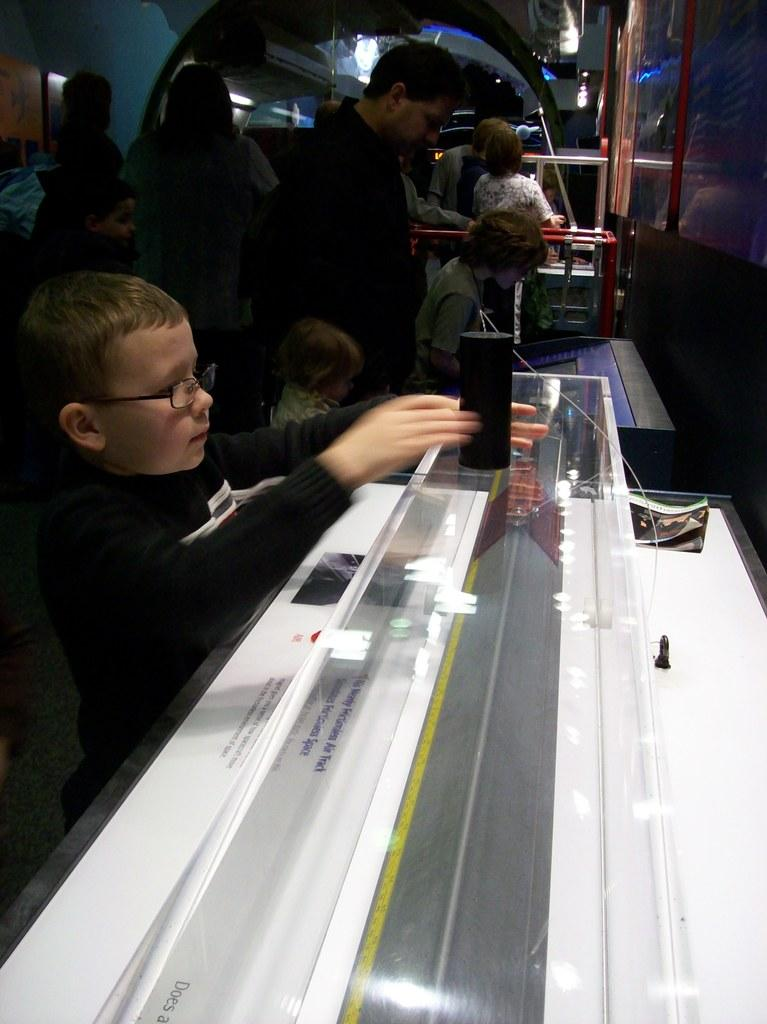What is the main object in the image? There is a device in the image. What is written or displayed on the white surface? There is text visible on a white surface. Who is present in the image? There are kids in the image. What can be seen in the background of the image? There are people and objects visible in the background of the image. How many woolen roses can be seen in the image? There is no mention of wool or roses in the image, so it is not possible to determine the number of woolen roses present. 